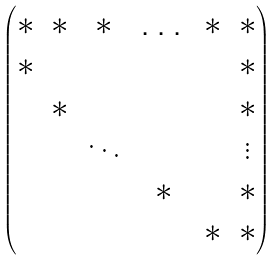Convert formula to latex. <formula><loc_0><loc_0><loc_500><loc_500>\begin{pmatrix} \ast & \ast & \ast & \dots & \ast & \ast \\ \ast & & & & & \ast \\ & \ast & & & & \ast \\ & & \ddots & & & \vdots \\ & & & \ast & & \ast \\ & & & & \ast & \ast \end{pmatrix}</formula> 